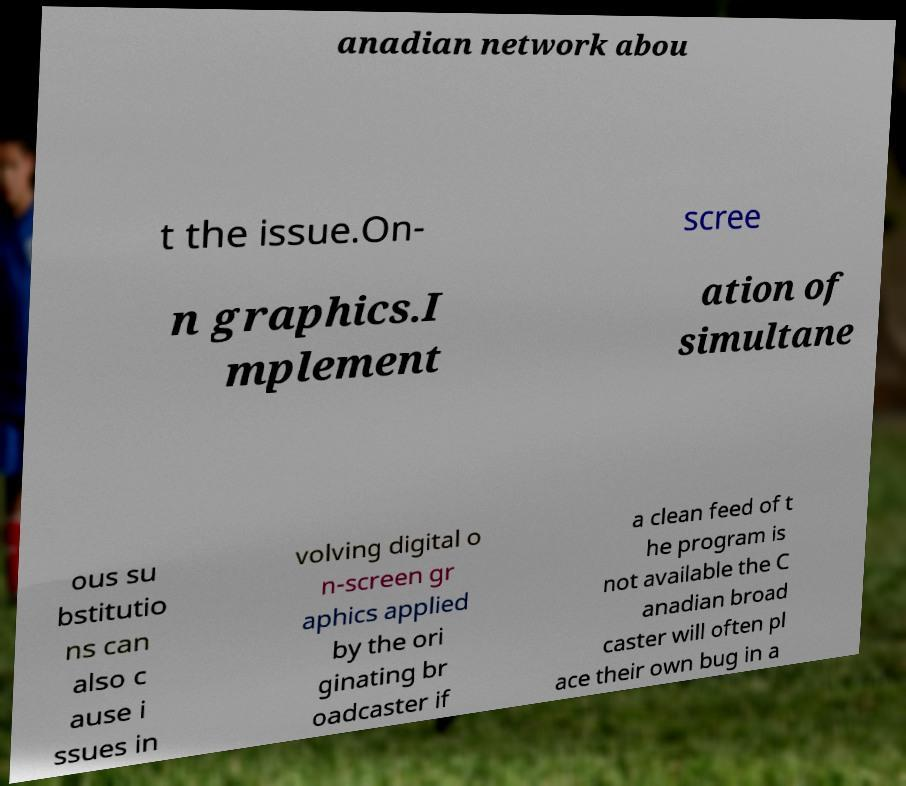Can you accurately transcribe the text from the provided image for me? anadian network abou t the issue.On- scree n graphics.I mplement ation of simultane ous su bstitutio ns can also c ause i ssues in volving digital o n-screen gr aphics applied by the ori ginating br oadcaster if a clean feed of t he program is not available the C anadian broad caster will often pl ace their own bug in a 